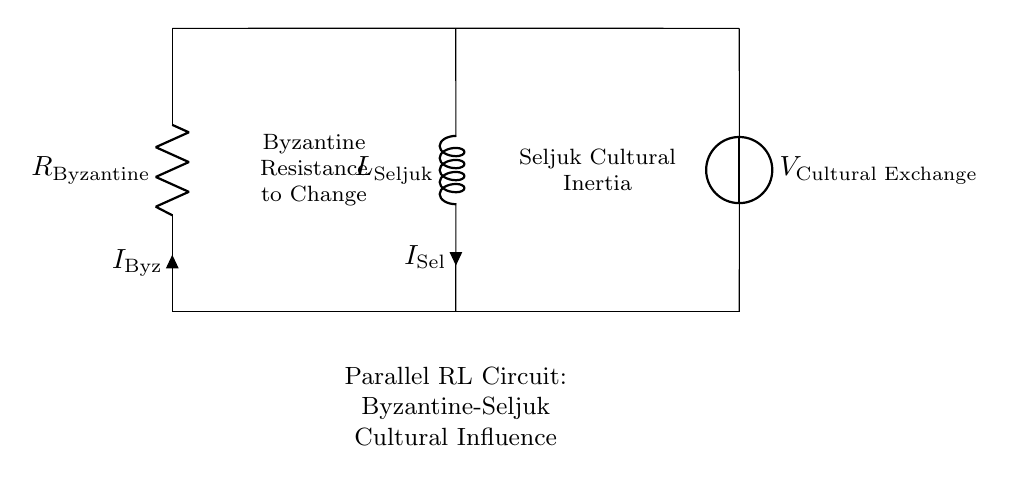What is the component representing Byzantine influence? The component representing Byzantine influence is the resistor, labeled as "R_Byzantine." In an RL circuit, resistors reduce current flow, which symbolizes the resistance of the Byzantine culture to adopting external influences.
Answer: R_Byzantine What does the inductor symbolize in this circuit? The inductor, labeled as "L_Seljuk," symbolizes the cultural inertia of the Seljuk Turks. Inductors store energy in a magnetic field and resist changes to current, representing how the Seljuk culture might have been slow to change.
Answer: L_Seljuk What is the voltage source labeled as? The voltage source is labeled as "V_Cultural Exchange," indicating the driving force of cultural interactions between the Byzantine and Seljuk civilizations. This source provides the energy needed for the influences to flow.
Answer: V_Cultural Exchange What is indicated by the current labeled "I_Byz"? The current labeled "I_Byz" indicates the flow of cultural resistance from the Byzantine side, represented by the resistor in this parallel RL circuit. It signifies how much cultural influence is resisted by the Byzantine civilization.
Answer: I_Byz How do the components connect in this circuit? The components are connected in a parallel arrangement. The resistor and inductor are both connected across the same voltage source, which illustrates that both civilizations' cultural influences can coexist and exert influence simultaneously.
Answer: Parallel arrangement What does the text inside the resistor represent? The text inside the resistor ("Byzantine Resistance to Change") represents the idea that the Byzantine Empire had significant resistance to change, mirroring the electrical resistance that impedes current flow in the circuit.
Answer: Byzantine Resistance to Change What cultural characteristic does the text inside the inductor refer to? The text inside the inductor ("Seljuk Cultural Inertia") refers to the idea that Seljuk culture had a tendency to maintain its traditions and resist rapid changes, akin to how an inductor opposes changes in current flow.
Answer: Seljuk Cultural Inertia 